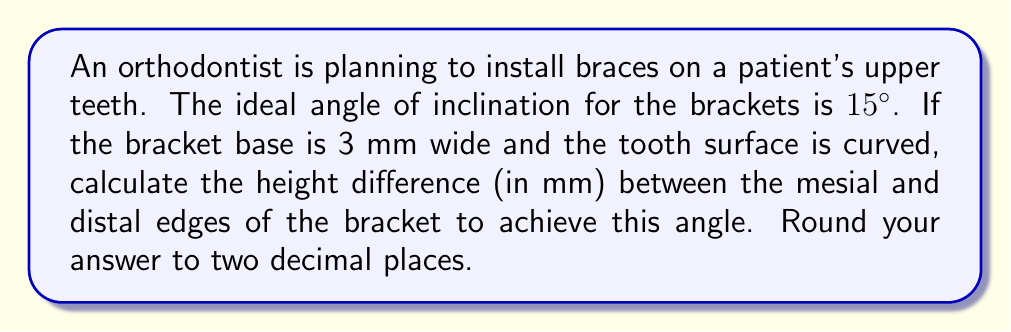Can you solve this math problem? Let's approach this step-by-step:

1) We can visualize this as a right triangle, where:
   - The base of the triangle is the width of the bracket (3 mm)
   - The angle we want to achieve is 15°
   - We need to find the opposite side of this triangle (the height difference)

2) In a right triangle, we can use the tangent function to find the opposite side:

   $$ \tan(\theta) = \frac{\text{opposite}}{\text{adjacent}} $$

3) Rearranging this formula:

   $$ \text{opposite} = \tan(\theta) \times \text{adjacent} $$

4) Plugging in our values:

   $$ \text{height difference} = \tan(15°) \times 3\text{ mm} $$

5) Calculate:
   
   $$ \tan(15°) \approx 0.2679 $$
   
   $$ \text{height difference} = 0.2679 \times 3\text{ mm} = 0.8037\text{ mm} $$

6) Rounding to two decimal places:

   $$ \text{height difference} \approx 0.80\text{ mm} $$
Answer: 0.80 mm 